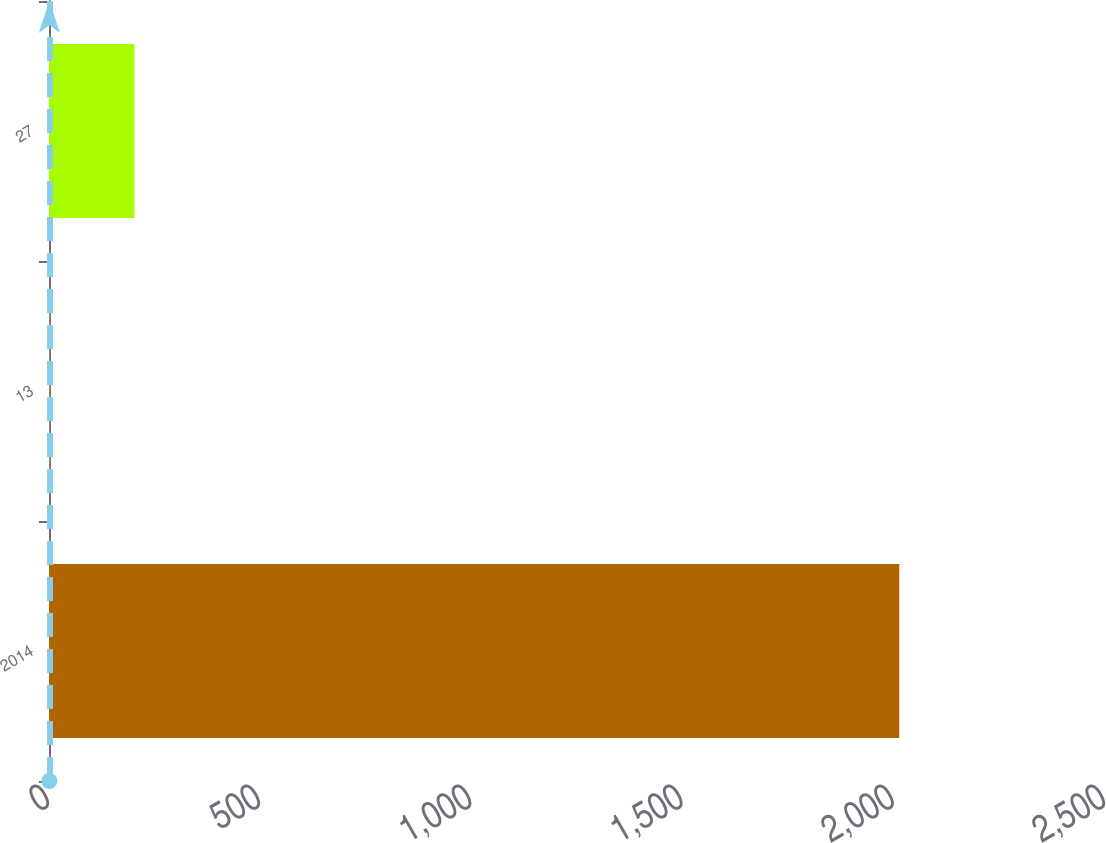<chart> <loc_0><loc_0><loc_500><loc_500><bar_chart><fcel>2014<fcel>13<fcel>27<nl><fcel>2013<fcel>1<fcel>202.2<nl></chart> 